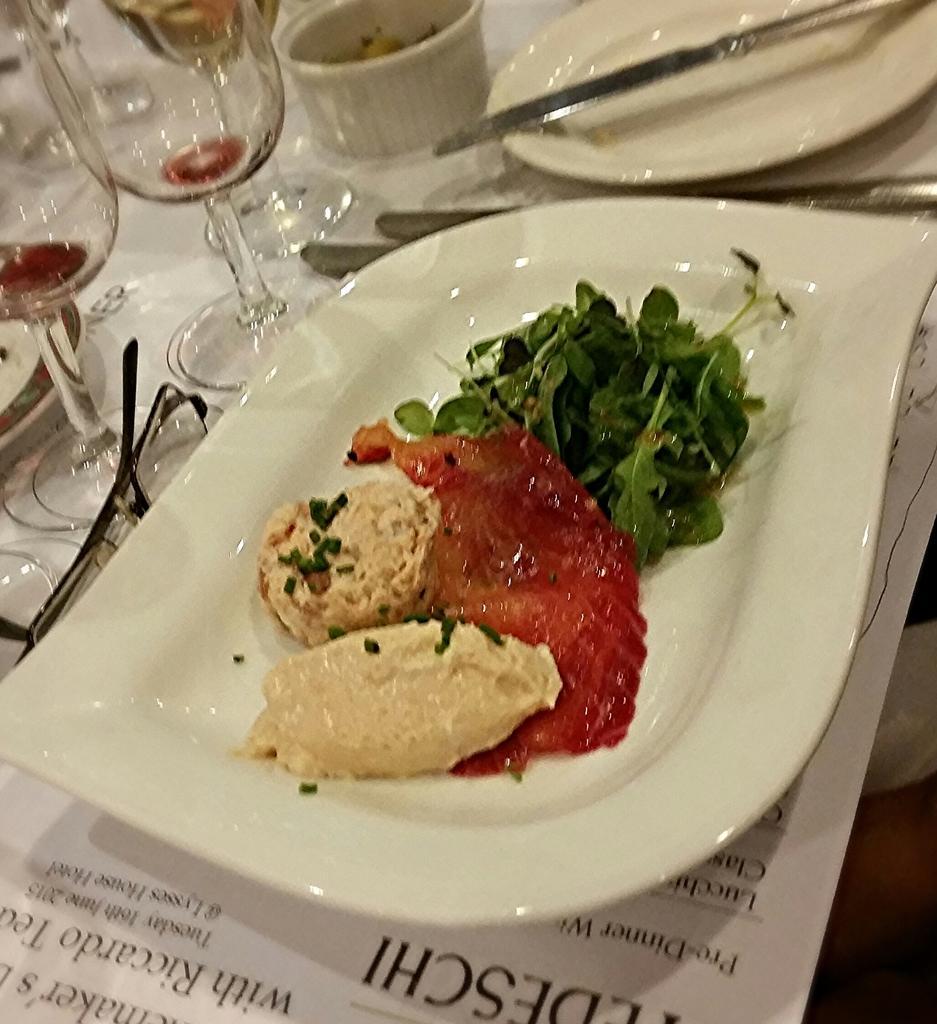Describe this image in one or two sentences. In this image there is a table. On the table there are glasses, bowls, plates, cutlery and a spectacles. There is food on the plate. Below the plate there is a paper. There is text on the paper. 